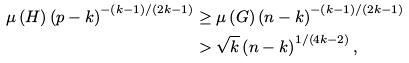<formula> <loc_0><loc_0><loc_500><loc_500>\mu \left ( H \right ) \left ( p - k \right ) ^ { - \left ( k - 1 \right ) / \left ( 2 k - 1 \right ) } & \geq \mu \left ( G \right ) \left ( n - k \right ) ^ { - \left ( k - 1 \right ) / \left ( 2 k - 1 \right ) } \\ & > \sqrt { k } \left ( n - k \right ) ^ { 1 / \left ( 4 k - 2 \right ) } ,</formula> 